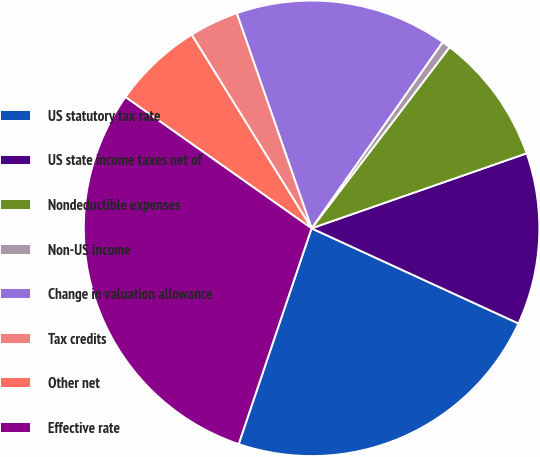Convert chart. <chart><loc_0><loc_0><loc_500><loc_500><pie_chart><fcel>US statutory tax rate<fcel>US state income taxes net of<fcel>Nondeductible expenses<fcel>Non-US income<fcel>Change in valuation allowance<fcel>Tax credits<fcel>Other net<fcel>Effective rate<nl><fcel>23.33%<fcel>12.2%<fcel>9.3%<fcel>0.6%<fcel>15.09%<fcel>3.5%<fcel>6.4%<fcel>29.59%<nl></chart> 